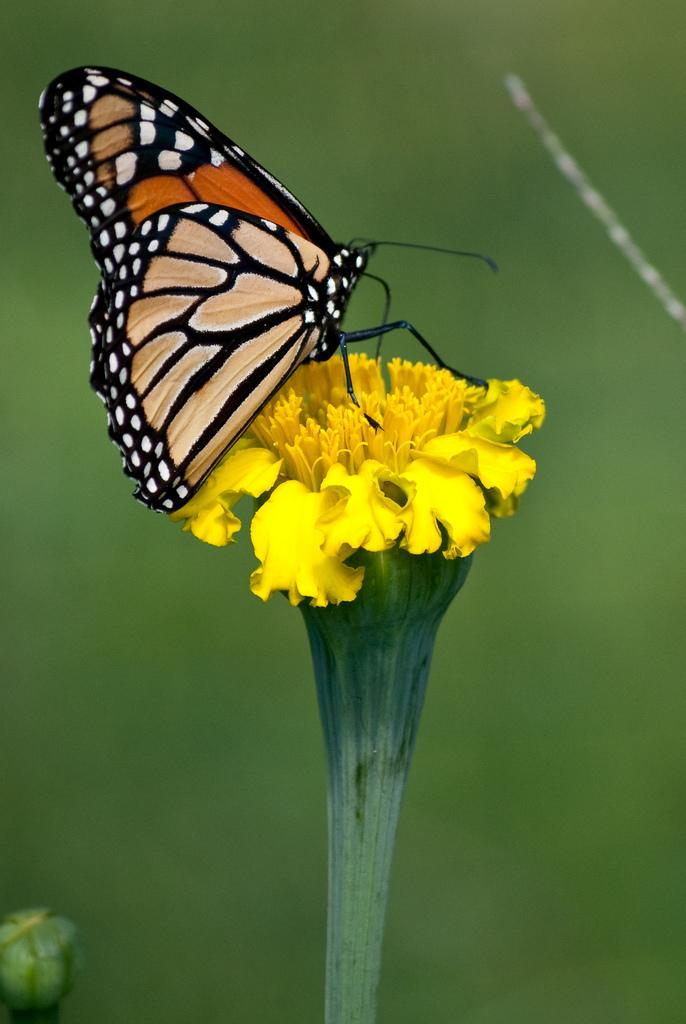What is the main subject of the image? There is a butterfly in the image. Where is the butterfly located? The butterfly is on a flower. What color is the flower? The flower is yellow. What color is the background of the image? The background of the image is green. What can be seen at the bottom of the image? There is a bud at the bottom of the image. What type of bun is the butterfly using to fly in the image? There is no bun present in the image, and butterflies do not use buns to fly. 